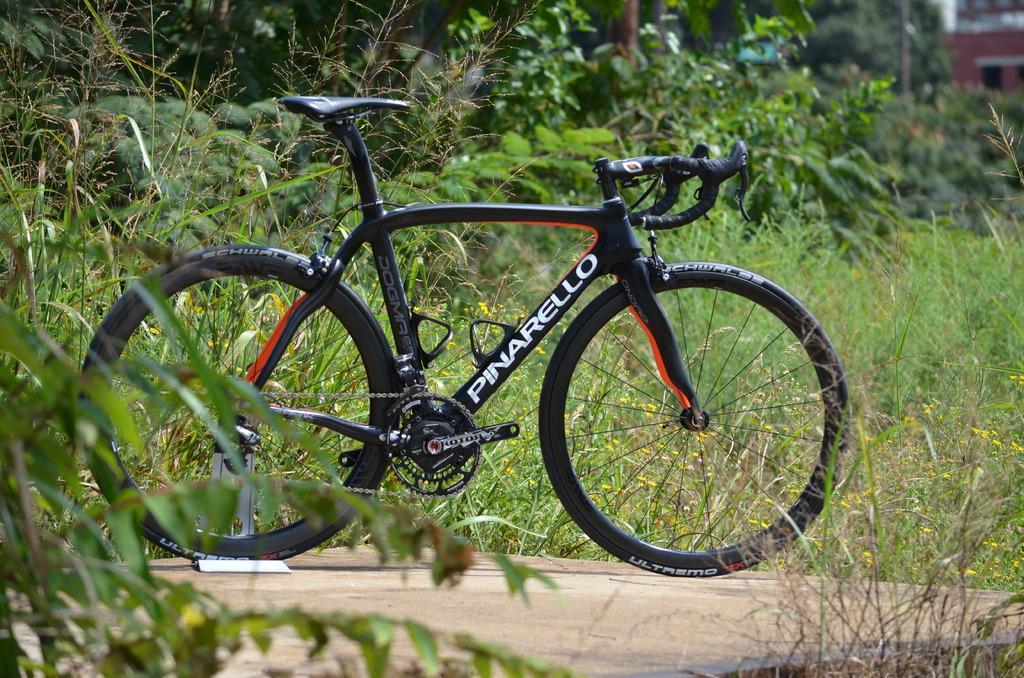In one or two sentences, can you explain what this image depicts? in this image I can see the bicycle on the road. The bicycle is in black color and something is written on it. In the background I can see many trees. To the right I can see the brown color building. 